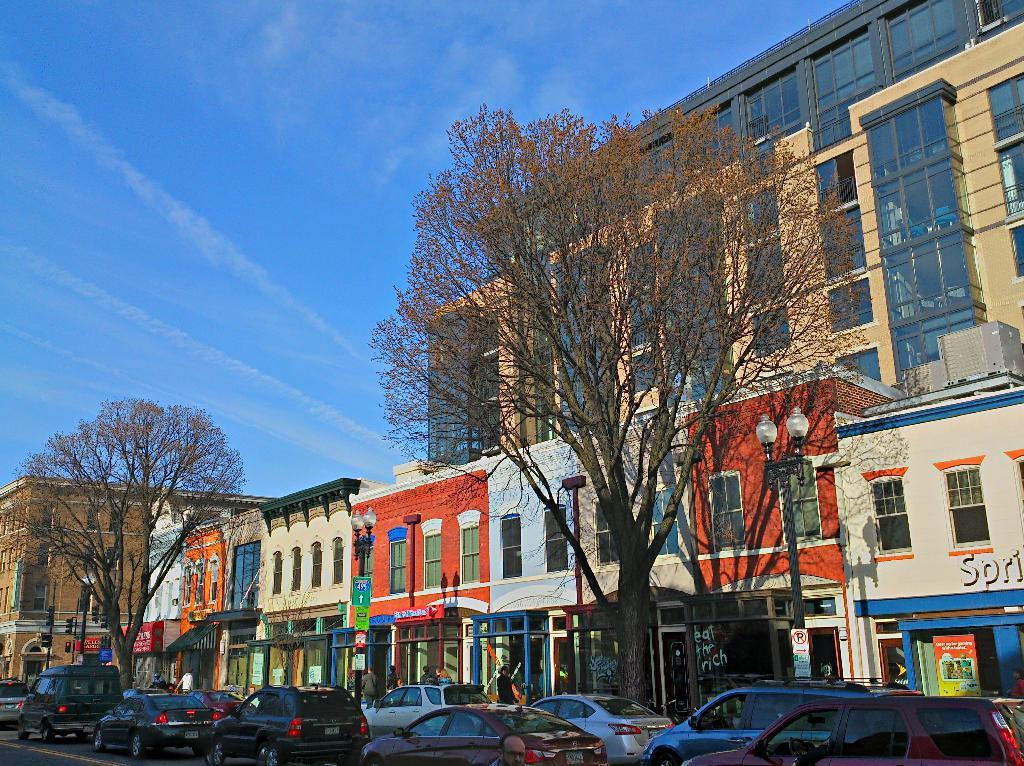Please provide a concise description of this image. Here in this picture, in the front we can see number of cars present on the road and we can also see lamp posts and trees present and beside that we can see number of buildings and stores with windows and doors present on the ground and we can also see hoardings and banners present and we can also see sign boards present and we can see clouds in the sky. 